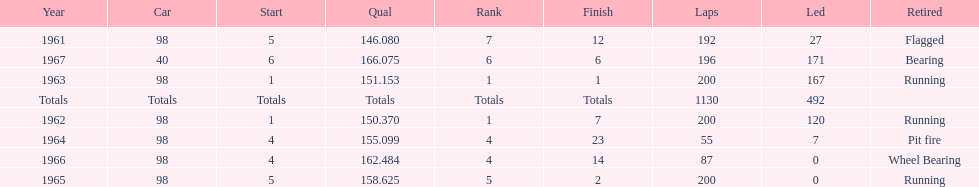Previous to 1965, when did jones have a number 5 start at the indy 500? 1961. 